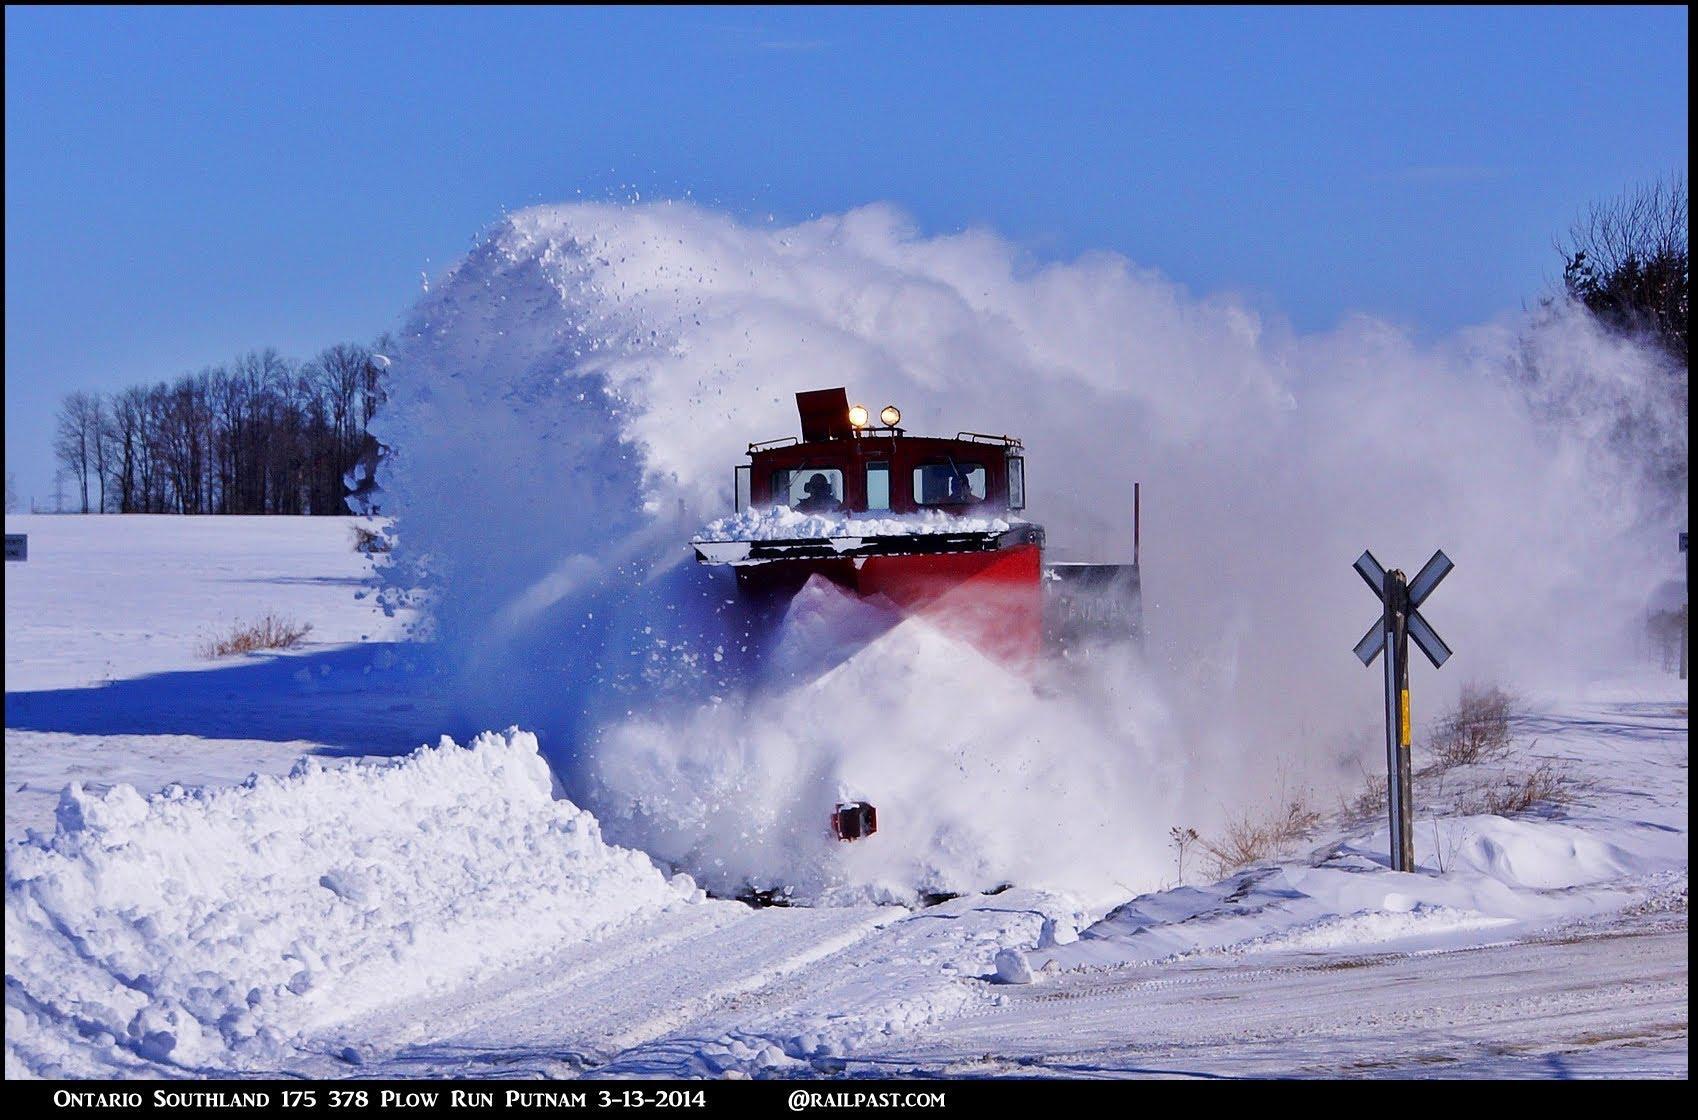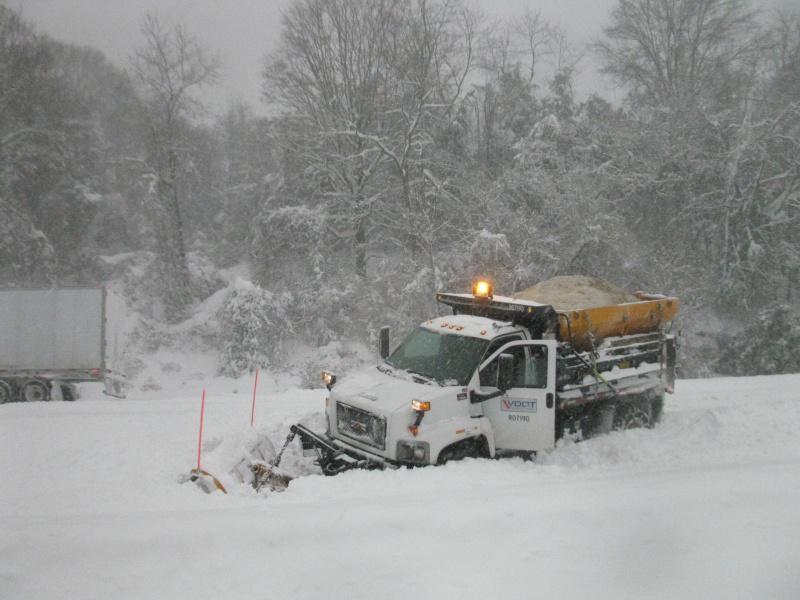The first image is the image on the left, the second image is the image on the right. Considering the images on both sides, is "there are at least two vehicles in one of the images" valid? Answer yes or no. No. The first image is the image on the left, the second image is the image on the right. Analyze the images presented: Is the assertion "More than one snowplow truck is present on a snowy road." valid? Answer yes or no. No. 